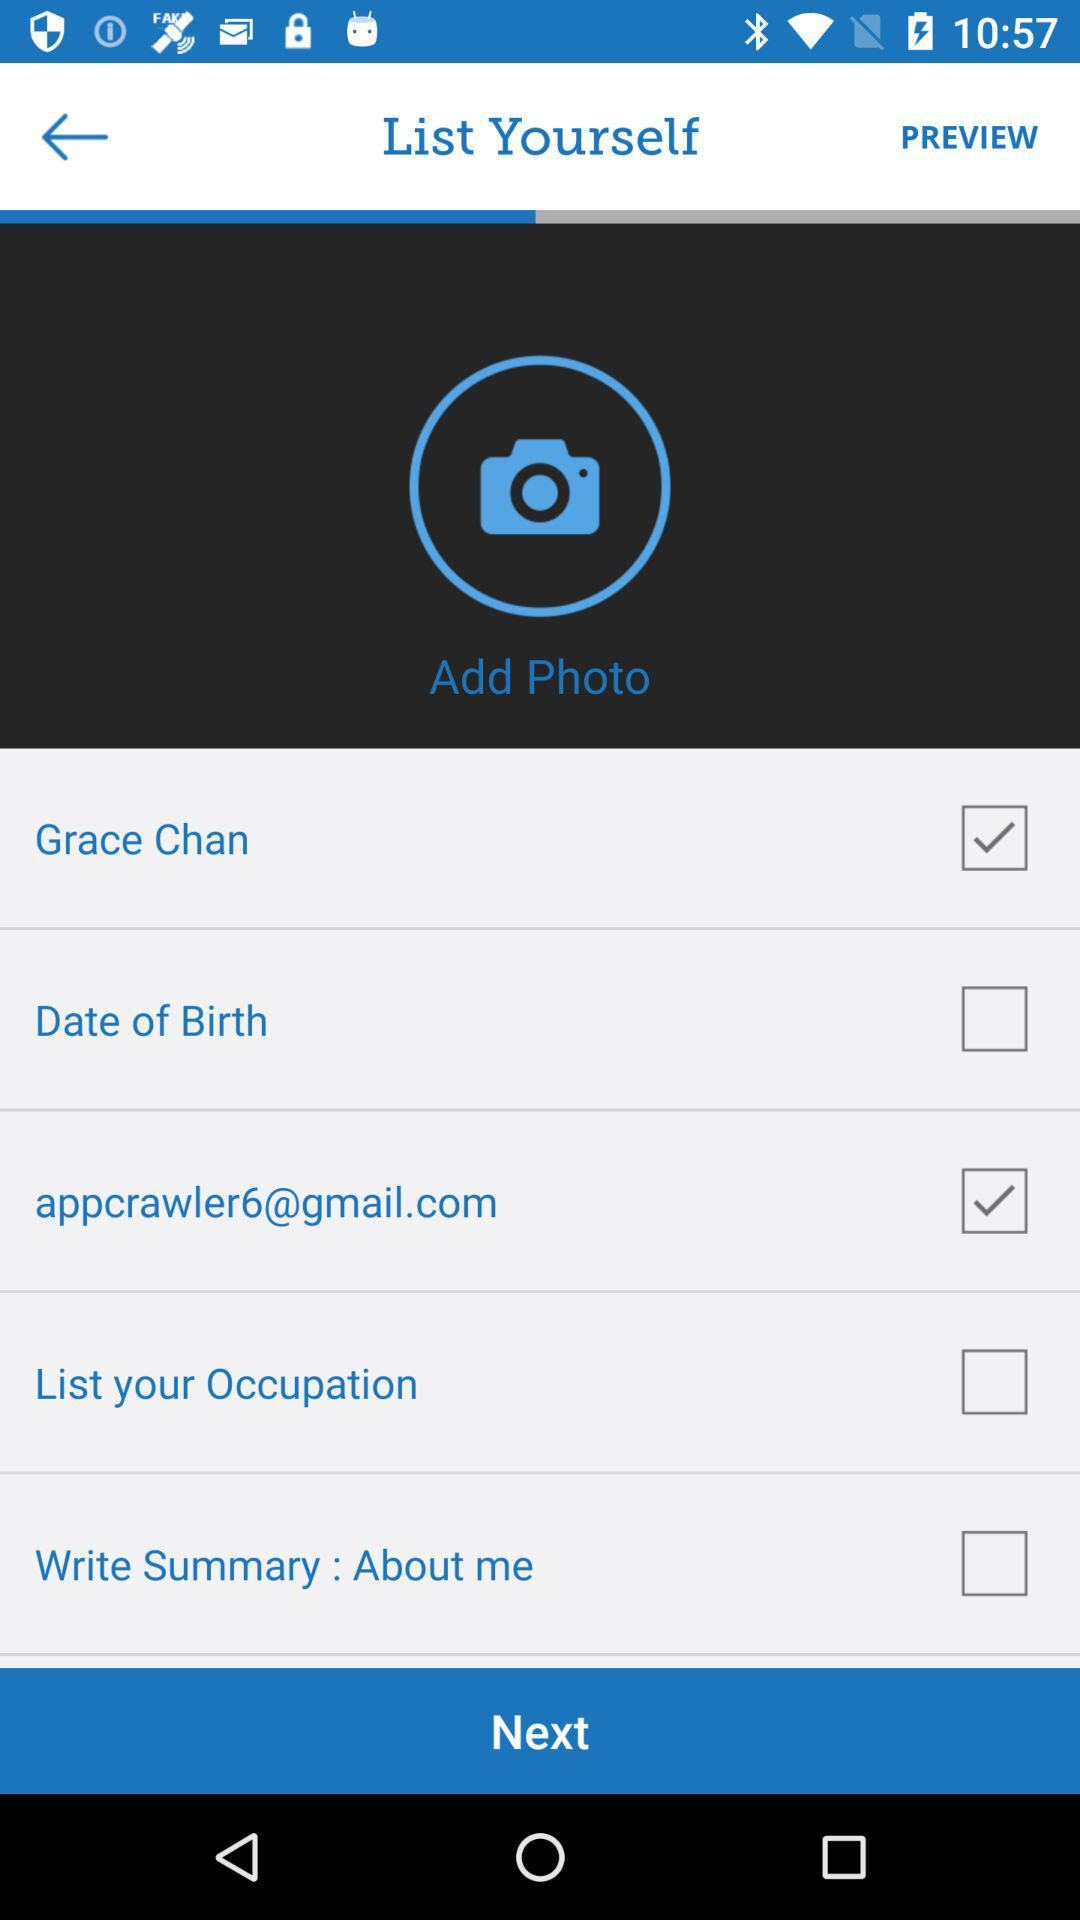What is the email address? The email address is appcrawler6@gmail.com. 